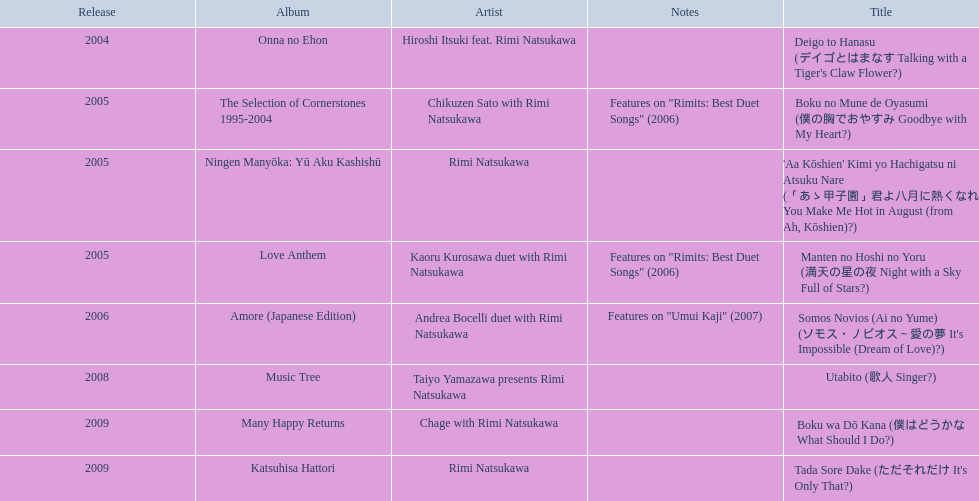When was onna no ehon released? 2004. When was the selection of cornerstones 1995-2004 released? 2005. What was released in 2008? Music Tree. 